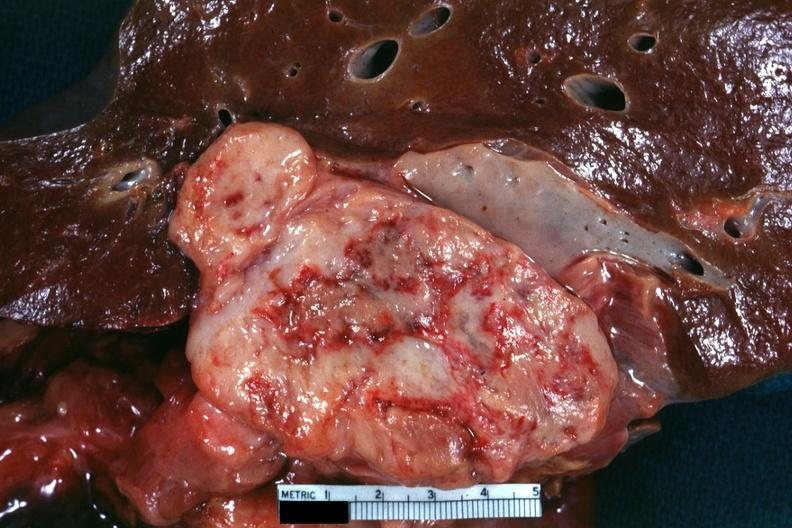what does this section showing liver with tumor mass in hilar area tumor show?
Answer the question using a single word or phrase. Cut surface fish flesh appearance and extensive necrosis very good for illustrating appearance of a sarcoma 